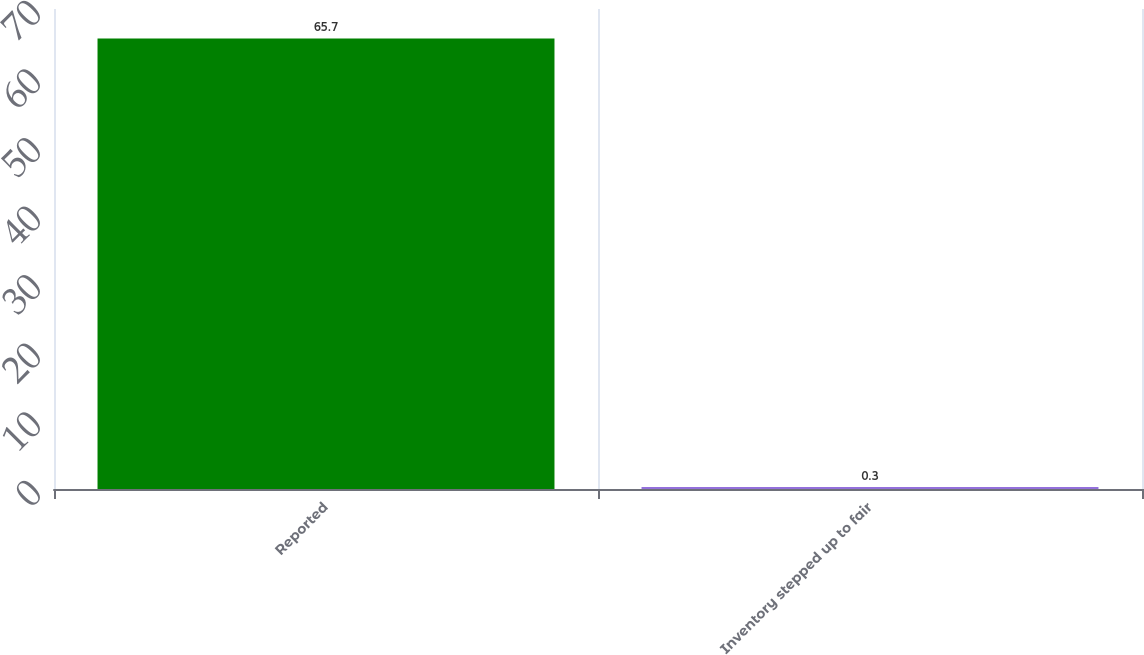Convert chart to OTSL. <chart><loc_0><loc_0><loc_500><loc_500><bar_chart><fcel>Reported<fcel>Inventory stepped up to fair<nl><fcel>65.7<fcel>0.3<nl></chart> 